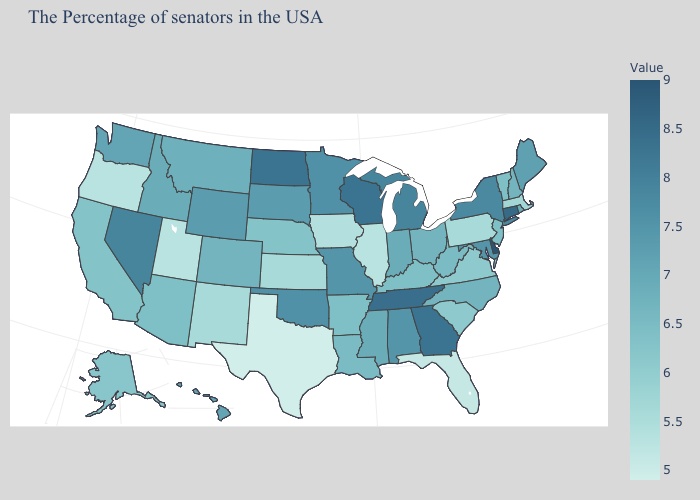Does North Dakota have the highest value in the MidWest?
Be succinct. Yes. Does Nevada have the highest value in the West?
Keep it brief. Yes. Does New Mexico have the lowest value in the West?
Quick response, please. No. Does Washington have the lowest value in the West?
Give a very brief answer. No. Is the legend a continuous bar?
Give a very brief answer. Yes. Which states hav the highest value in the Northeast?
Be succinct. Connecticut. 